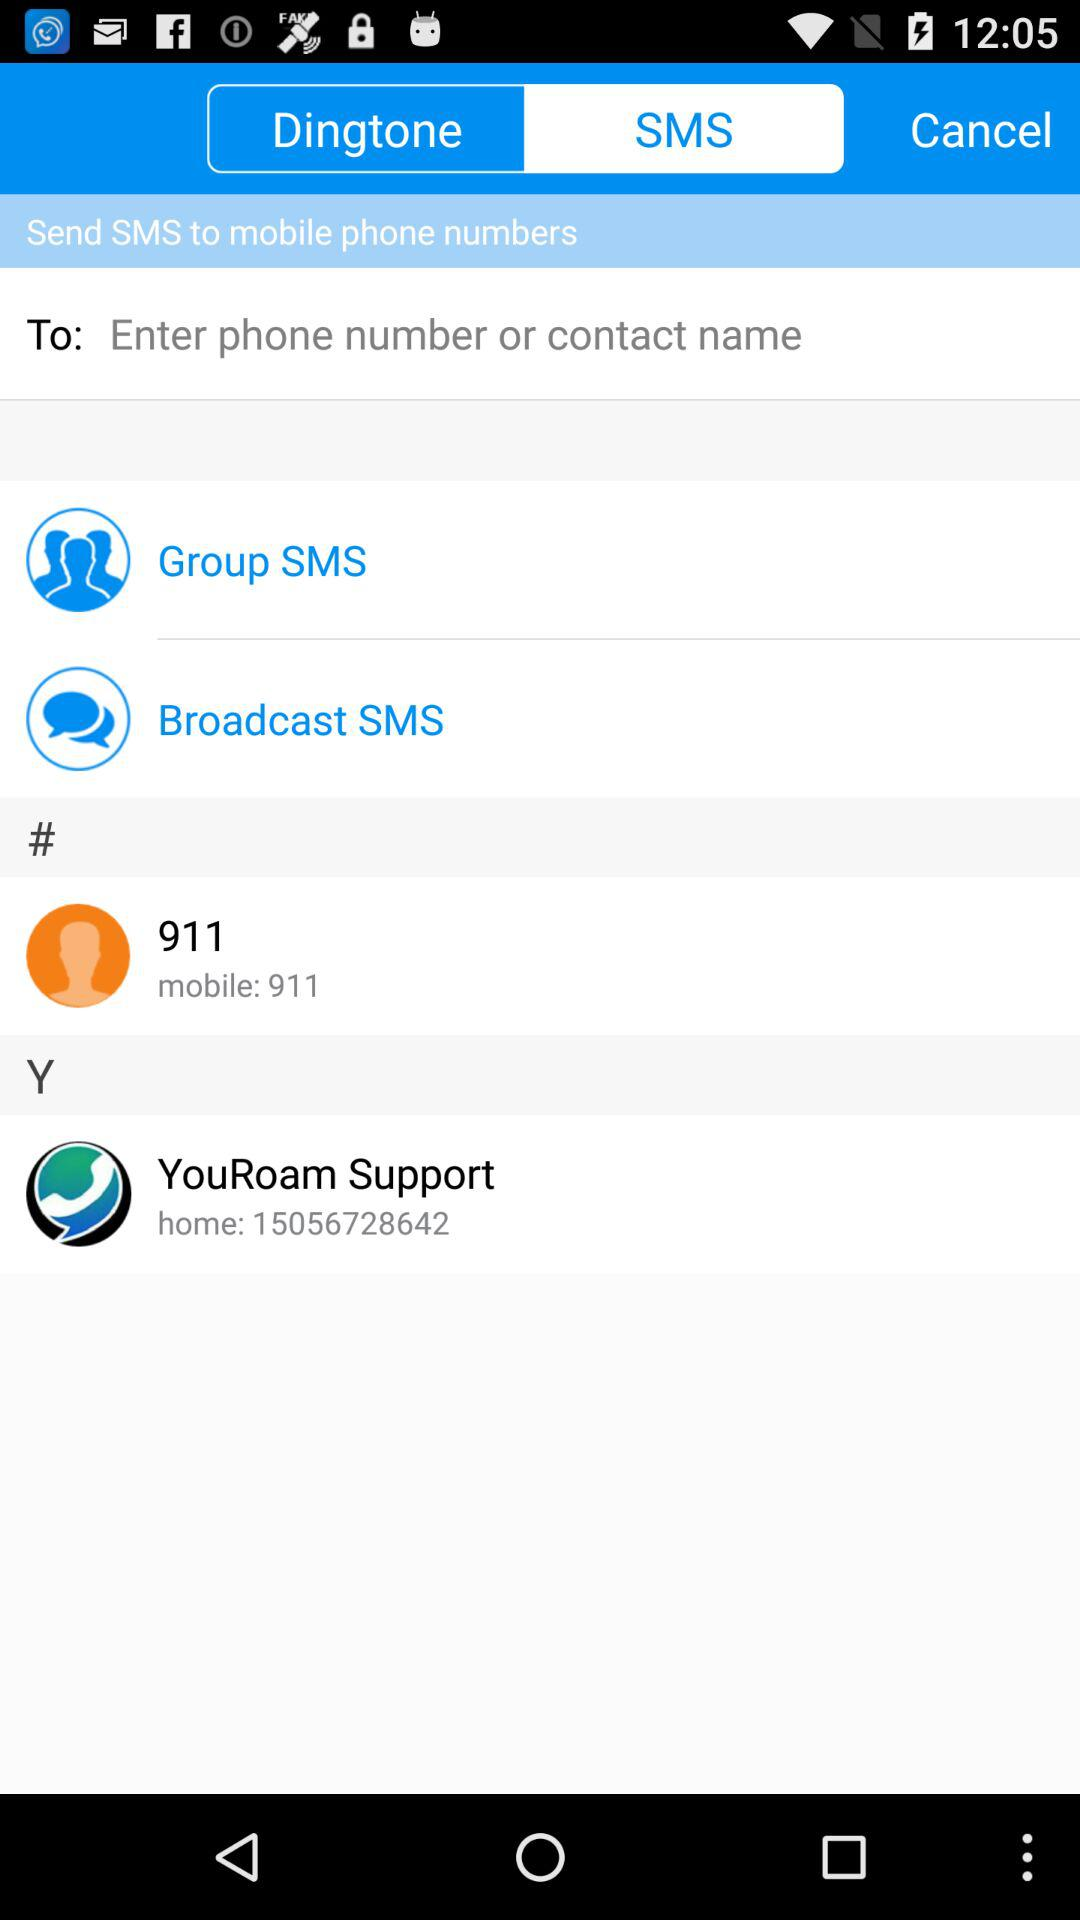What is the mobile number? The mobile number is 911. 